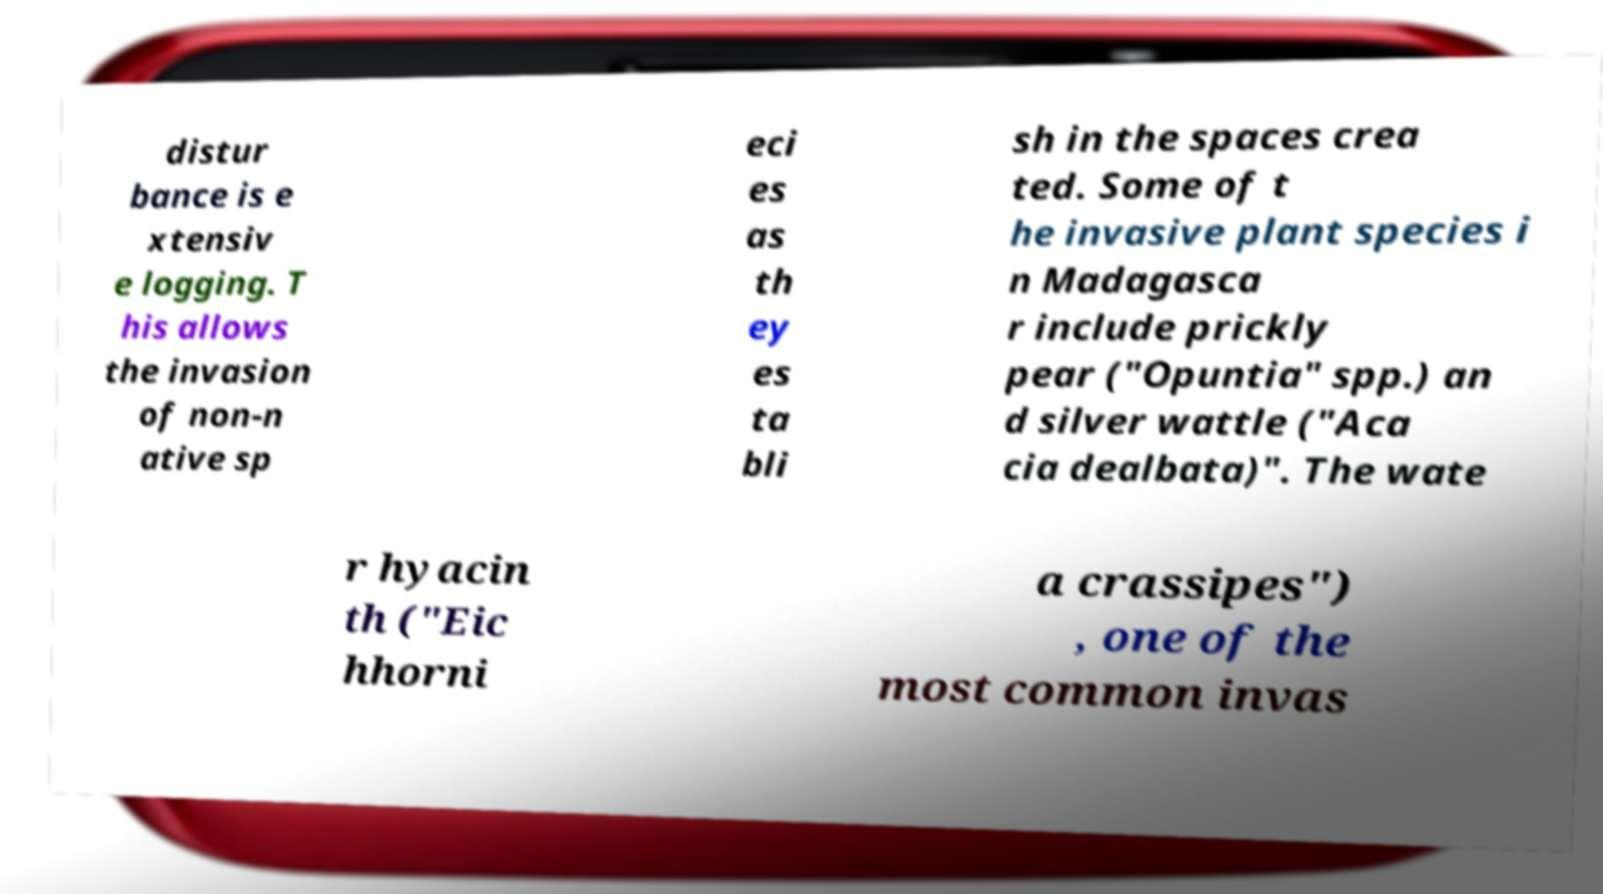Could you extract and type out the text from this image? distur bance is e xtensiv e logging. T his allows the invasion of non-n ative sp eci es as th ey es ta bli sh in the spaces crea ted. Some of t he invasive plant species i n Madagasca r include prickly pear ("Opuntia" spp.) an d silver wattle ("Aca cia dealbata)". The wate r hyacin th ("Eic hhorni a crassipes") , one of the most common invas 